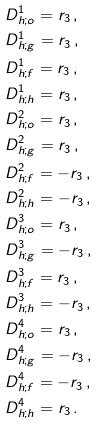<formula> <loc_0><loc_0><loc_500><loc_500>& D _ { h ; o } ^ { 1 } = r _ { 3 } \, , \\ & D _ { h ; g } ^ { 1 } = r _ { 3 } \, , \\ & D _ { h ; f } ^ { 1 } = r _ { 3 } \, , \\ & D _ { h ; h } ^ { 1 } = r _ { 3 } \, , \\ \quad & D _ { h ; o } ^ { 2 } = r _ { 3 } \, , \\ & D _ { h ; g } ^ { 2 } = r _ { 3 } \, , \\ & D _ { h ; f } ^ { 2 } = - r _ { 3 } \, , \\ & D _ { h ; h } ^ { 2 } = - r _ { 3 } \, , \\ \quad & D _ { h ; o } ^ { 3 } = r _ { 3 } \, , \\ & D _ { h ; g } ^ { 3 } = - r _ { 3 } \, , \\ & D _ { h ; f } ^ { 3 } = r _ { 3 } \, , \\ & D _ { h ; h } ^ { 3 } = - r _ { 3 } \, , \\ \quad & D _ { h ; o } ^ { 4 } = r _ { 3 } \, , \\ & D _ { h ; g } ^ { 4 } = - r _ { 3 } \, , \\ & D _ { h ; f } ^ { 4 } = - r _ { 3 } \, , \\ & D _ { h ; h } ^ { 4 } = r _ { 3 } \, . \\</formula> 